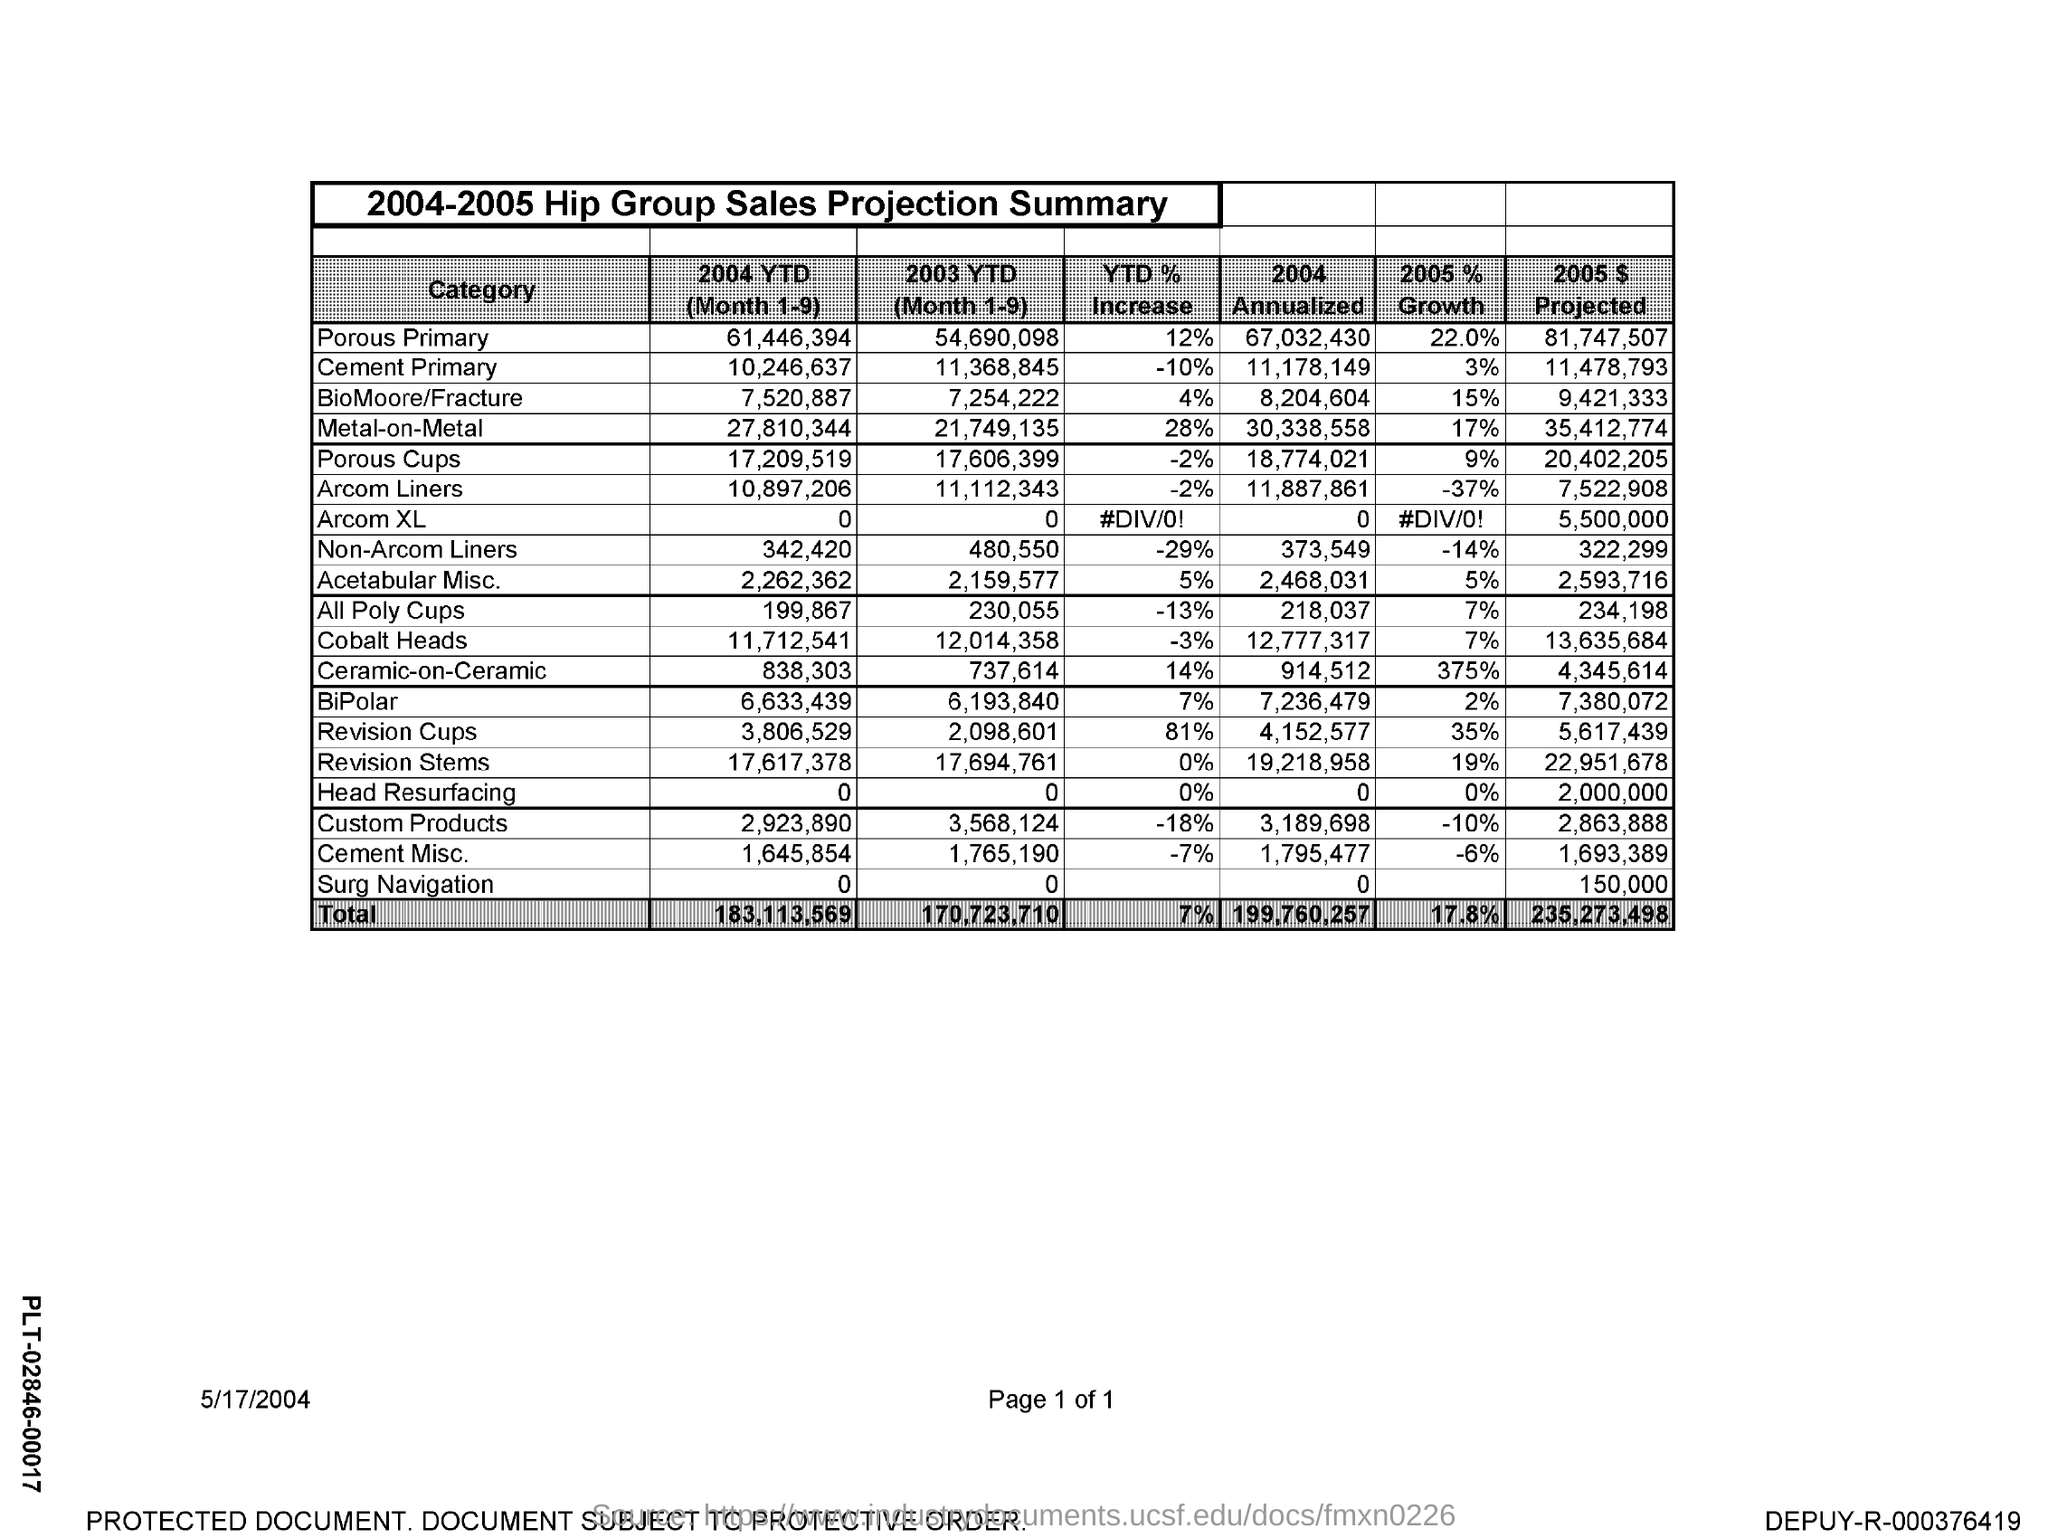Identify some key points in this picture. The date mentioned in the document is May 17th, 2004. The table is titled '2004-2005 Hip Group Sales Projection Summary.' 